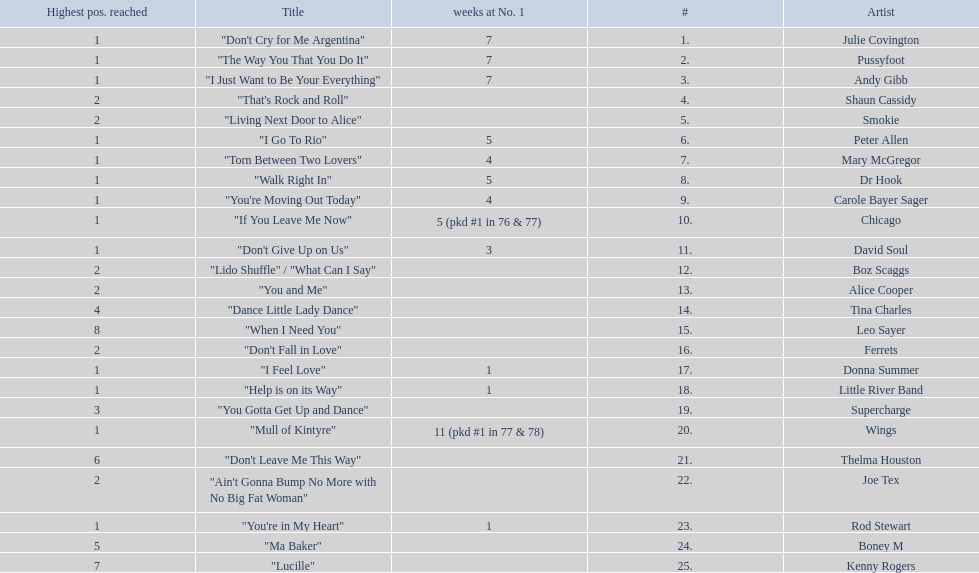How long is the longest amount of time spent at number 1? 11 (pkd #1 in 77 & 78). What song spent 11 weeks at number 1? "Mull of Kintyre". Would you mind parsing the complete table? {'header': ['Highest pos. reached', 'Title', 'weeks at No. 1', '#', 'Artist'], 'rows': [['1', '"Don\'t Cry for Me Argentina"', '7', '1.', 'Julie Covington'], ['1', '"The Way You That You Do It"', '7', '2.', 'Pussyfoot'], ['1', '"I Just Want to Be Your Everything"', '7', '3.', 'Andy Gibb'], ['2', '"That\'s Rock and Roll"', '', '4.', 'Shaun Cassidy'], ['2', '"Living Next Door to Alice"', '', '5.', 'Smokie'], ['1', '"I Go To Rio"', '5', '6.', 'Peter Allen'], ['1', '"Torn Between Two Lovers"', '4', '7.', 'Mary McGregor'], ['1', '"Walk Right In"', '5', '8.', 'Dr Hook'], ['1', '"You\'re Moving Out Today"', '4', '9.', 'Carole Bayer Sager'], ['1', '"If You Leave Me Now"', '5 (pkd #1 in 76 & 77)', '10.', 'Chicago'], ['1', '"Don\'t Give Up on Us"', '3', '11.', 'David Soul'], ['2', '"Lido Shuffle" / "What Can I Say"', '', '12.', 'Boz Scaggs'], ['2', '"You and Me"', '', '13.', 'Alice Cooper'], ['4', '"Dance Little Lady Dance"', '', '14.', 'Tina Charles'], ['8', '"When I Need You"', '', '15.', 'Leo Sayer'], ['2', '"Don\'t Fall in Love"', '', '16.', 'Ferrets'], ['1', '"I Feel Love"', '1', '17.', 'Donna Summer'], ['1', '"Help is on its Way"', '1', '18.', 'Little River Band'], ['3', '"You Gotta Get Up and Dance"', '', '19.', 'Supercharge'], ['1', '"Mull of Kintyre"', '11 (pkd #1 in 77 & 78)', '20.', 'Wings'], ['6', '"Don\'t Leave Me This Way"', '', '21.', 'Thelma Houston'], ['2', '"Ain\'t Gonna Bump No More with No Big Fat Woman"', '', '22.', 'Joe Tex'], ['1', '"You\'re in My Heart"', '1', '23.', 'Rod Stewart'], ['5', '"Ma Baker"', '', '24.', 'Boney M'], ['7', '"Lucille"', '', '25.', 'Kenny Rogers']]} What band had a number 1 hit with this song? Wings. 